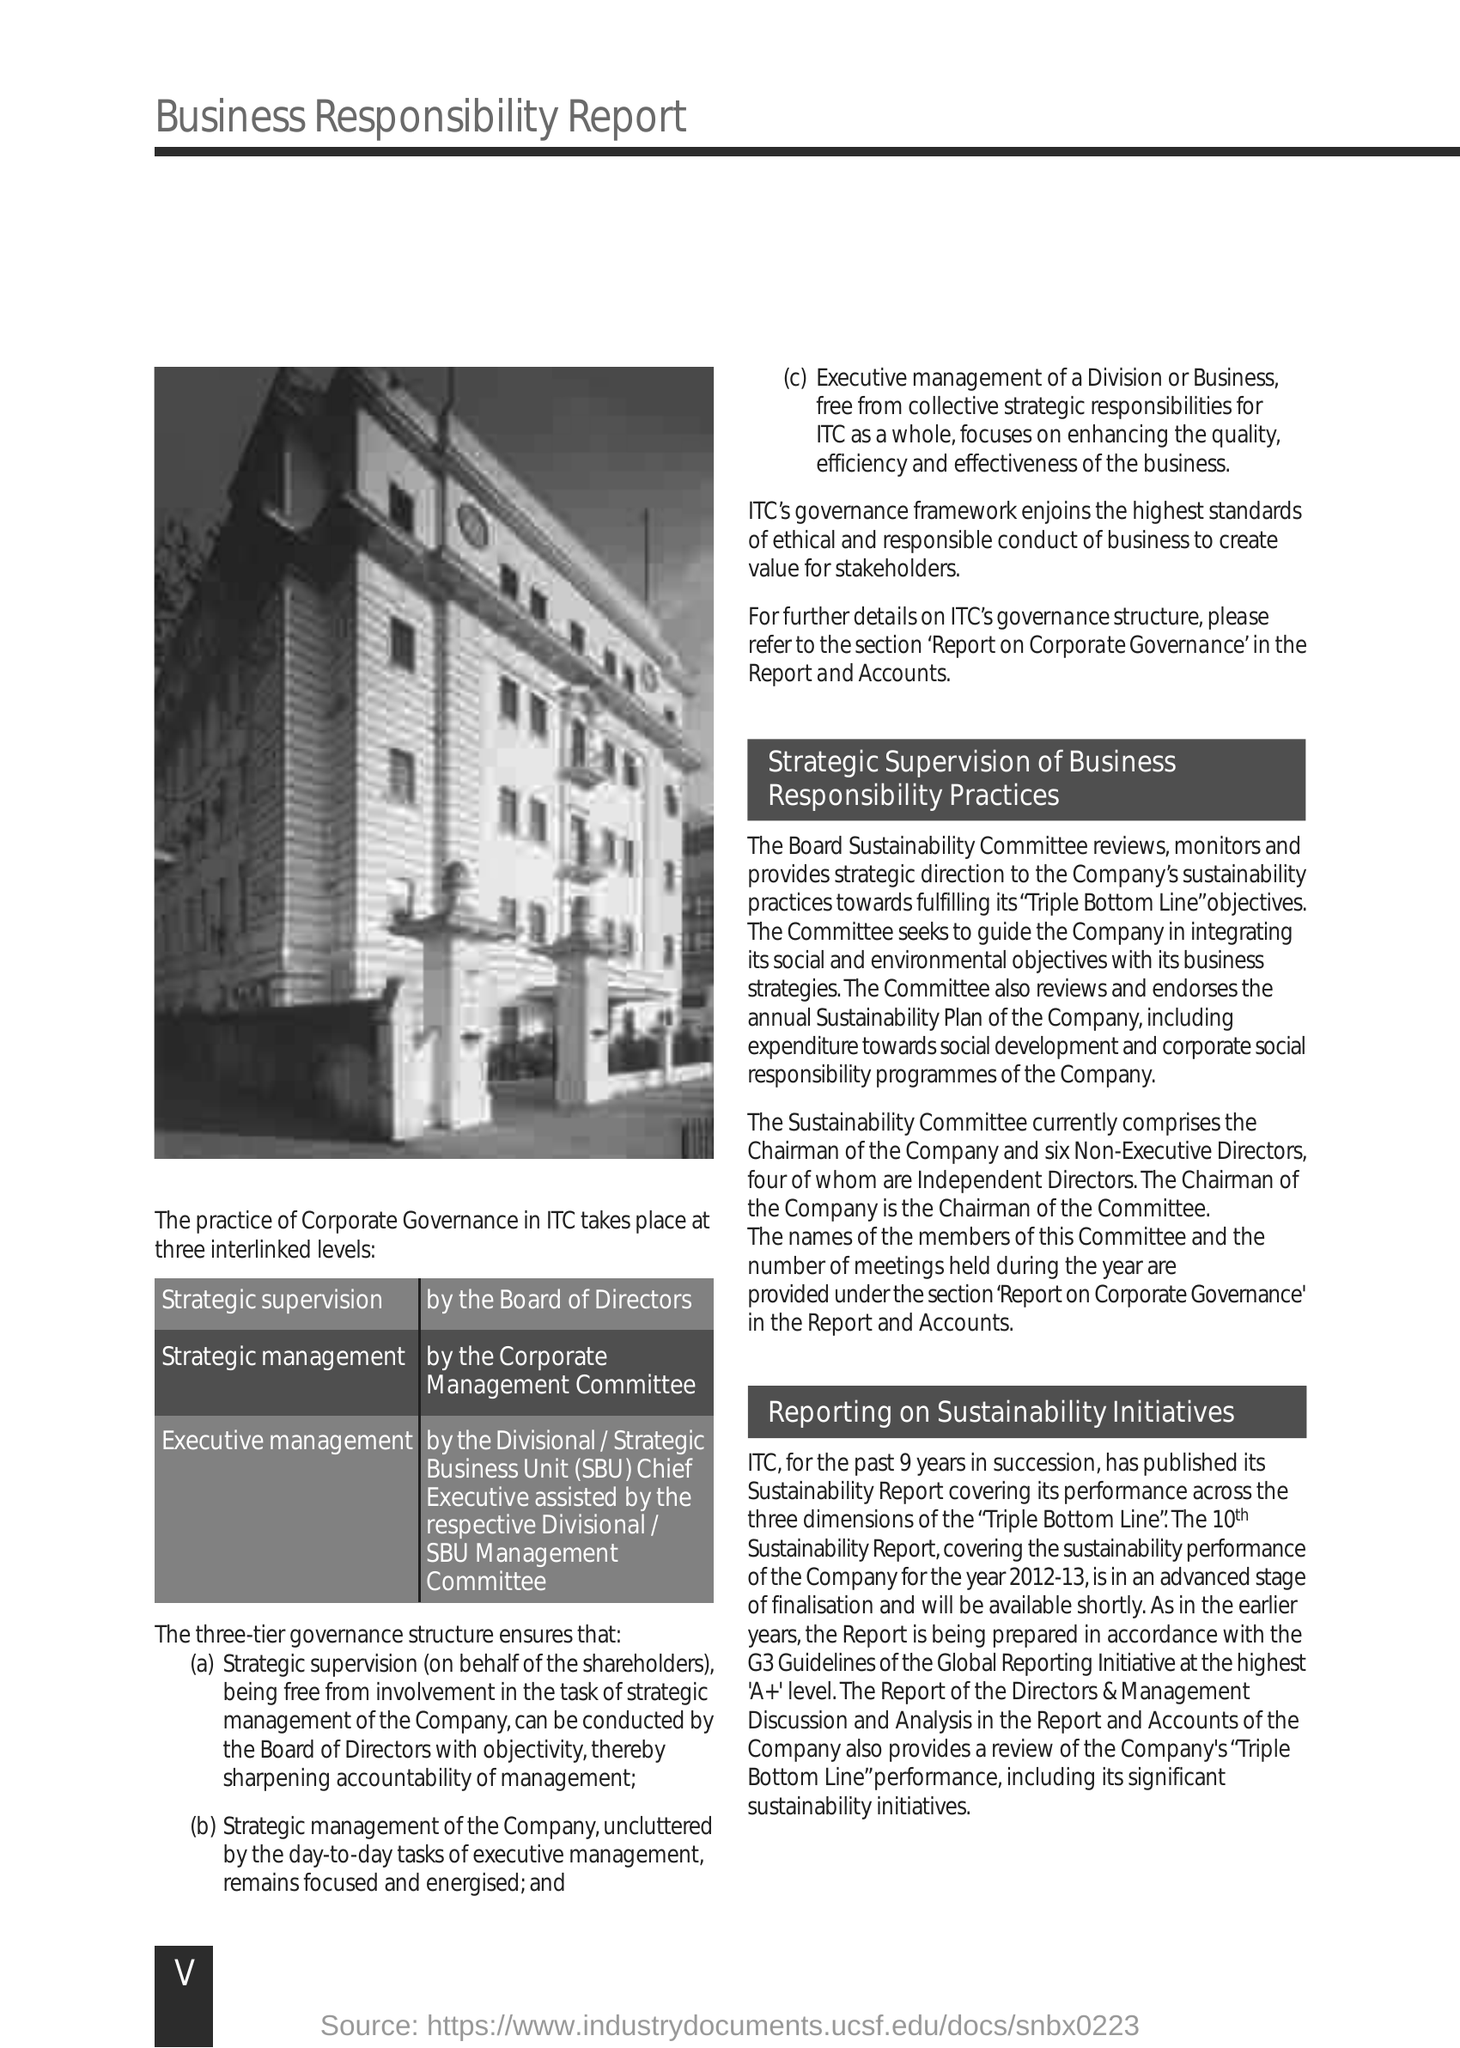What "Report" is this?
Offer a very short reply. Business responsibility report. "The practice of Corporate Governance in ITC takes place at" how many interlinked levels?
Give a very brief answer. Three. What is the first level of "practice of Corporate Governance in ITC"?
Keep it short and to the point. Strategic supervision. What is the second level of "practice of Corporate Governance in ITC"?
Make the answer very short. Strategic management. What is the third level of "practice of Corporate Governance in ITC"?
Offer a very short reply. Executive management. What is the expansion of "SBU"?
Make the answer very short. Strategic business unit. Who is the "Chairman of the Committee"?
Your answer should be very brief. The Chairman of the Company. "The Sustainability Committee currently comprises" how many "Non-Executive Directors"?
Keep it short and to the point. Six. What is the first subheading given in the Report?
Give a very brief answer. Strategic supervision of business responsibility practices. What is the Page number given at the left bottom corner of the page?
Your answer should be compact. V. 